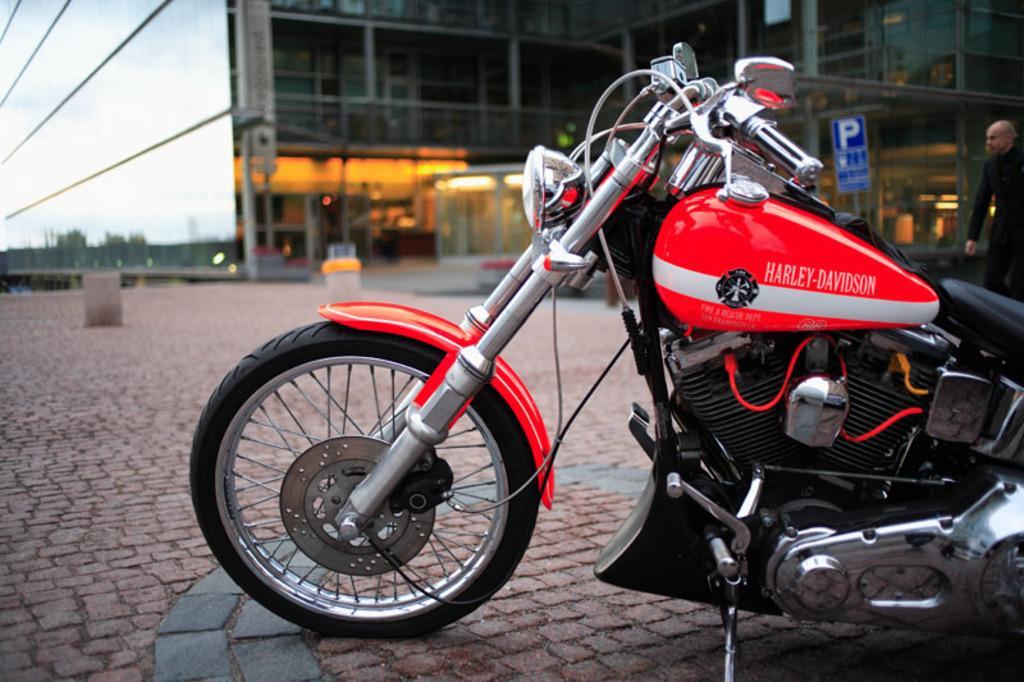In one or two sentences, can you explain what this image depicts? In this picture there is a red color Harley Davidson bike in the right corner and there is a building in the background. 